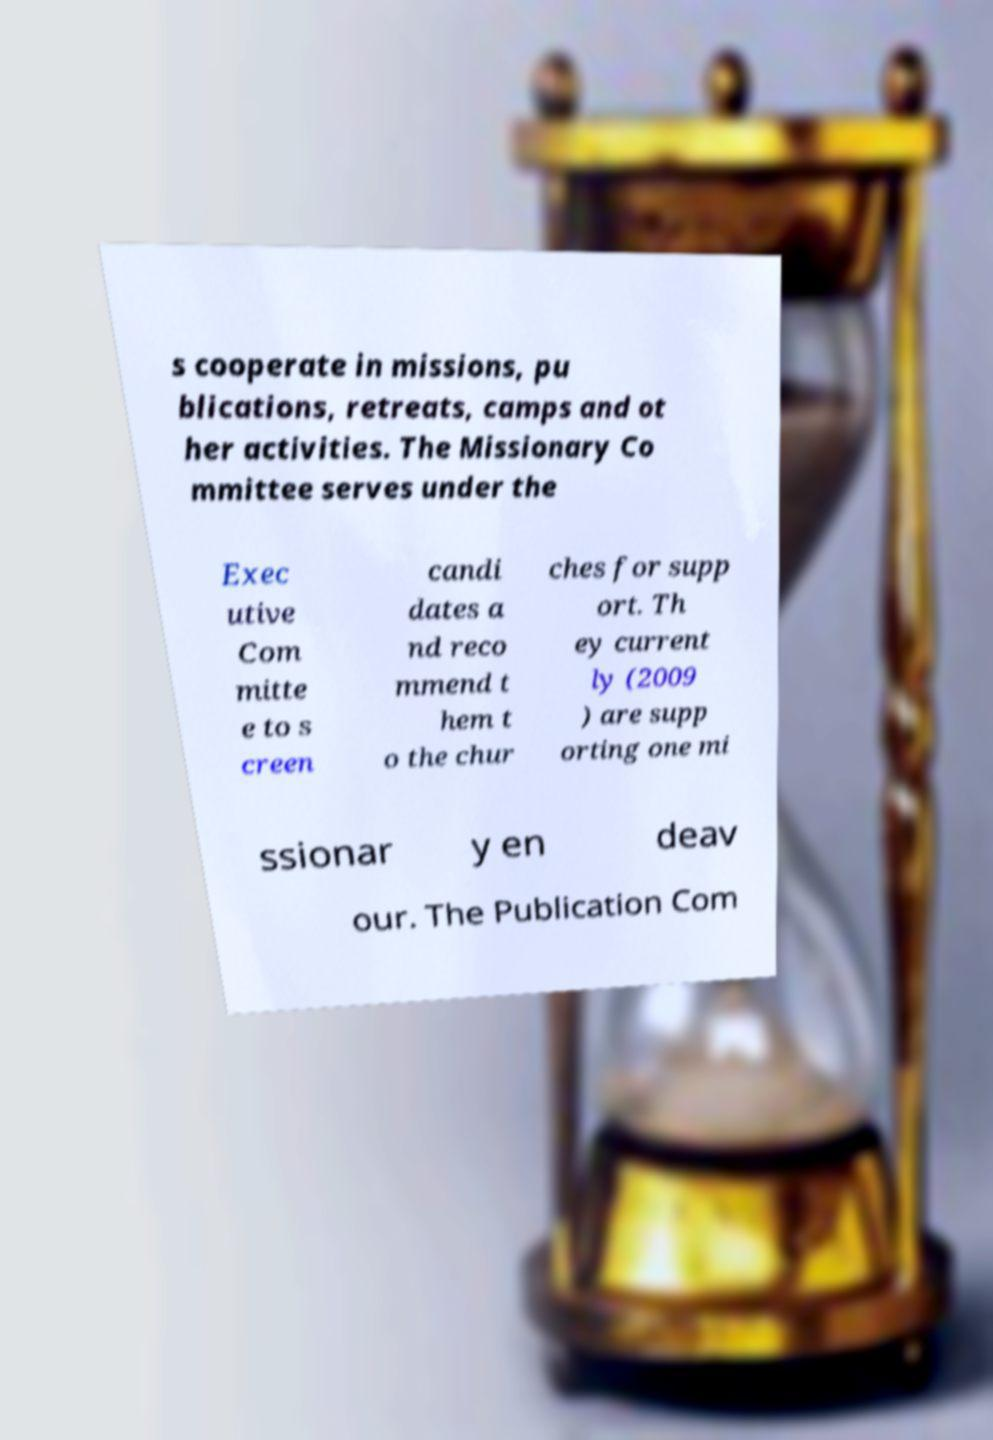Please identify and transcribe the text found in this image. s cooperate in missions, pu blications, retreats, camps and ot her activities. The Missionary Co mmittee serves under the Exec utive Com mitte e to s creen candi dates a nd reco mmend t hem t o the chur ches for supp ort. Th ey current ly (2009 ) are supp orting one mi ssionar y en deav our. The Publication Com 